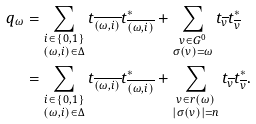<formula> <loc_0><loc_0><loc_500><loc_500>q _ { \omega } & = \sum _ { \substack { i \in \{ 0 , 1 \} \\ ( \omega , i ) \in \Delta } } t _ { \overline { ( \omega , i ) } } t _ { \overline { ( \omega , i ) } } ^ { * } + \sum _ { \substack { v \in G ^ { 0 } \\ \sigma ( v ) = \omega } } t _ { \overline { v } } t _ { \overline { v } } ^ { * } \\ & = \sum _ { \substack { i \in \{ 0 , 1 \} \\ ( \omega , i ) \in \Delta } } t _ { \overline { ( \omega , i ) } } t _ { \overline { ( \omega , i ) } } ^ { * } + \sum _ { \substack { v \in r ( \omega ) \\ | \sigma ( v ) | = n } } t _ { \overline { v } } t _ { \overline { v } } ^ { * } .</formula> 